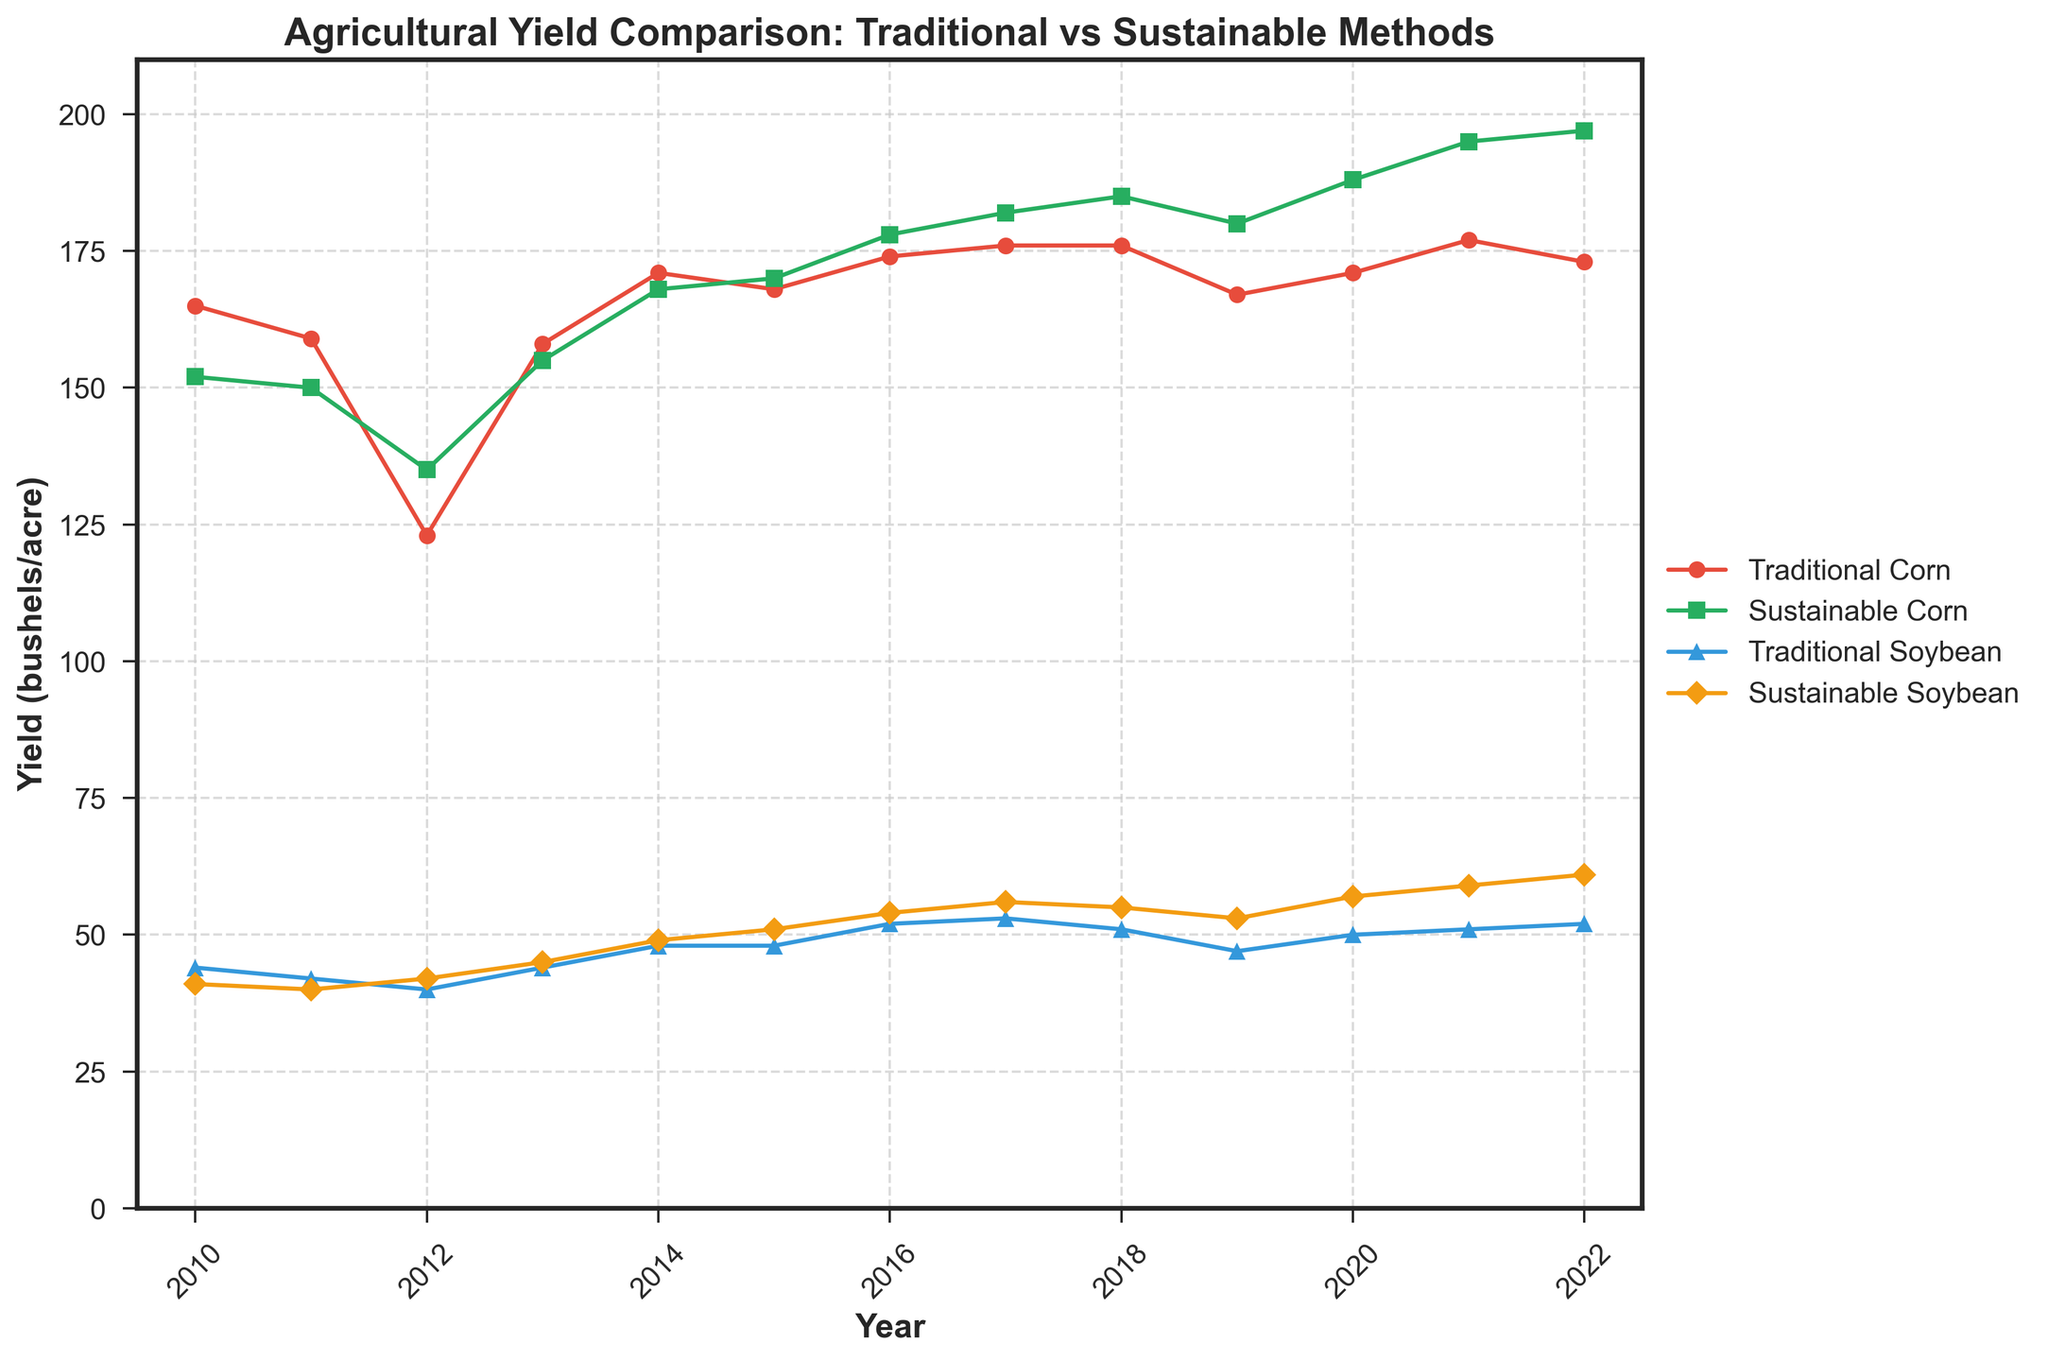What year did sustainable corn yield surpass traditional corn yield for the first time? Sustainable corn yield surpassed traditional corn yield for the first time in 2012. By inspecting the figure, we can see that the green line (sustainable corn) is above the red line (traditional corn) starting in 2012.
Answer: 2012 In which year did sustainable soybean yield reach its highest value? By looking at the figure, we can see that the orange line for sustainable soybean yield reaches its peak in 2022.
Answer: 2022 What is the difference between traditional corn yield and sustainable corn yield in 2022? In 2022, traditional corn yield is 173 bushels/acre and sustainable corn yield is 197 bushels/acre. The difference is 197 - 173 = 24 bushels/acre.
Answer: 24 bushels/acre Between 2010 and 2022, which year showed the largest gap between traditional and sustainable soybean yields? To find the largest gap, look for the year with the greatest difference between the blue line (traditional soybean) and the orange line (sustainable soybean). In 2022, the traditional soybean yield is 52 and the sustainable soybean yield is 61, making the gap 9 bushels/acre, which is the largest.
Answer: 2022 What is the average yield of sustainable corn over the entire period? Sum all the sustainable corn yields from 2010 to 2022 and divide by the number of years: (152 + 150 + 135 + 155 + 168 + 170 + 178 + 182 + 185 + 180 + 188 + 195 + 197) / 13 ≈ 172.54 bushels/acre.
Answer: ~172.54 bushels/acre Which method had a higher yield for corn in 2014, and by how much? In 2014, the traditional corn yield is 171 bushels/acre and sustainable corn yield is 168 bushels/acre. Traditional corn yield is higher by 171 - 168 = 3 bushels/acre.
Answer: Traditional by 3 bushels/acre How many years did it take for sustainable soybean yield to continuously increase from 2010? Sustainable soybean yield is shown to continuously increase each year from 2012 to 2022, making it a continuous increase over 11 years.
Answer: 11 years Is traditional corn yield ever higher than sustainable corn yield after 2013? Reviewing the plot for the years after 2013, the green line (sustainable corn) is always above the red line (traditional corn). Thus, traditional corn yield is never higher after 2013.
Answer: No How does the yield for traditional methods compare to sustainable methods for soybeans in 2015? For 2015, traditional soybean yield is 48 bushels/acre, and sustainable soybean yield is 51 bushels/acre. Sustainable soybean yield is higher by 3 bushels/acre.
Answer: Sustainable by 3 bushels/acre What are the approximate total yields for traditional and sustainable corn methods from 2010 to 2022? To get the total yields for traditional corn, sum the values from 2010 to 2022: 165 + 159 + 123 + 158 + 171 + 168 + 174 + 176 + 176 + 167 + 171 + 177 + 173 = 2158 bushels/acre. 
For sustainable corn, sum the values from 2010 to 2022: 152 + 150 + 135 + 155 + 168 + 170 + 178 + 182 + 185 + 180 + 188 + 195 + 197 = 2235 bushels/acre.
Answer: Traditional: 2158 bushels/acre, Sustainable: 2235 bushels/acre 